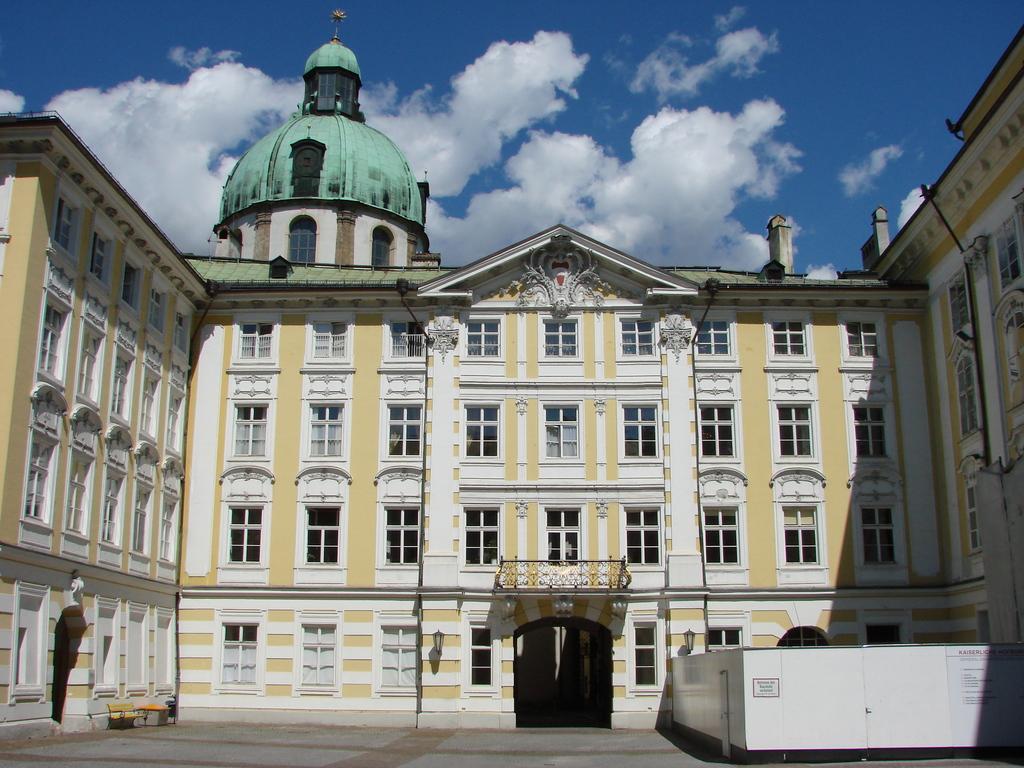Describe this image in one or two sentences. It is a building in white color. At the top it is the cloudy sky. 